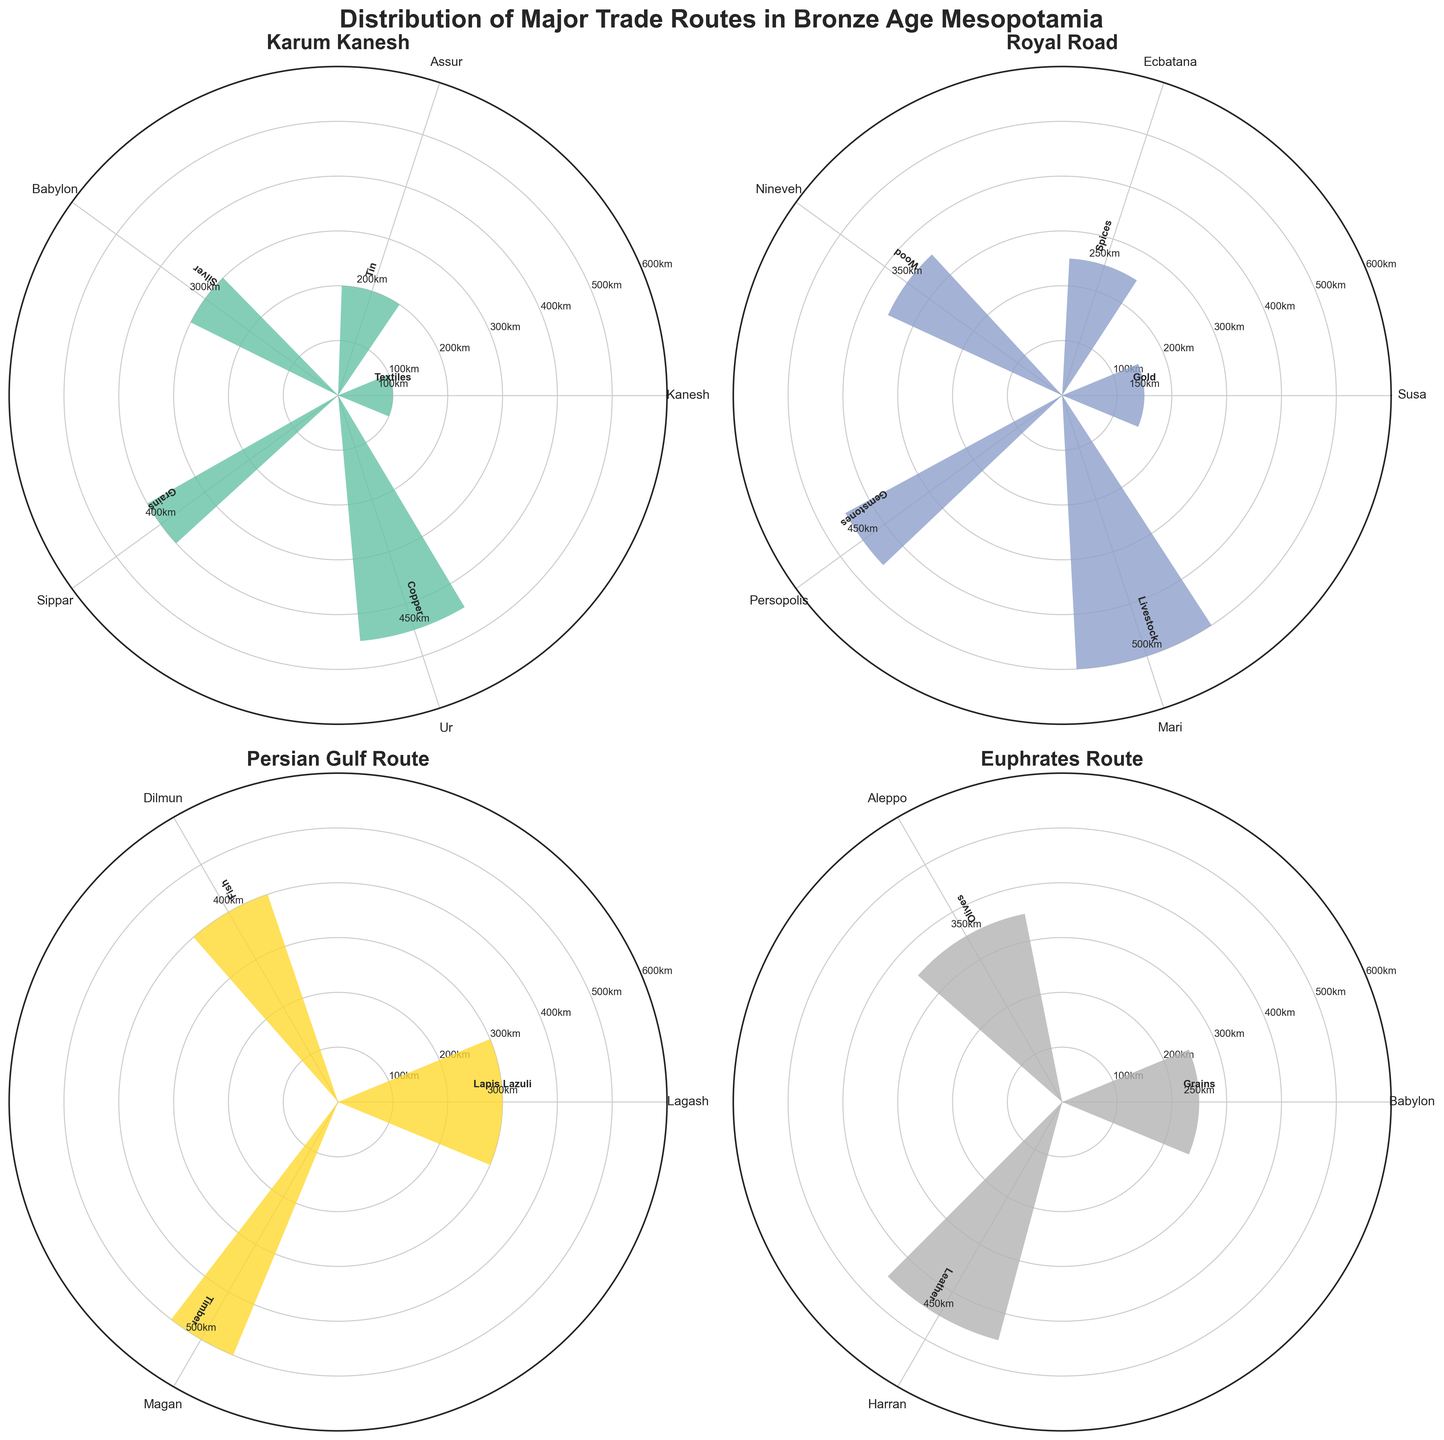What is the title of the figure? The title is displayed prominently at the top of the figure and reads 'Distribution of Major Trade Routes in Bronze Age Mesopotamia'
Answer: Distribution of Major Trade Routes in Bronze Age Mesopotamia Which trade route connects to the most trading centers? Each subplot represents a trade route, and counting the number of centers (bars) in each subplot shows that 'Karum Kanesh' and 'Royal Road' each have 5 centers, which is the most.
Answer: Karum Kanesh and Royal Road Which trading center on the Karum Kanesh route is the farthest distance from the starting point? On the subplot labeled 'Karum Kanesh', look for the longest bar which represents the farthest distance. 'Ur' has the longest bar.
Answer: Ur What kind of goods are traded most frequently on the Persian Gulf Route? On the subplot labeled 'Persian Gulf Route', count the frequency of each type of goods tagged near the bars. 'Lapis Lazuli' appears with the highest frequency of 6.
Answer: Lapis Lazuli Which two centers on the Royal Road have the same trading frequency? In the 'Royal Road' subplot, compare the width of the bars to find those of equal width. 'Ecbatana' and 'Mari' both have a frequency represented by a width of 4.
Answer: Ecbatana and Mari Which trade route has the shortest range of distances for its centers? By comparing the y-axis ranges of all subplots, 'Royal Road' ranges from 150 to 500, which covers 350 km, while other routes cover a wider range of distances.
Answer: Royal Road What is the combined frequency of goods traded to the cities of Kanesh and Assur on the Karum Kanesh route? In the 'Karum Kanesh' subplot, add the frequencies of 'Kanesh' (7) and 'Assur' (5): 7 + 5 = 12.
Answer: 12 On which route and to which center is livestock traded? From the labels near the bars, 'Royal Road' subplot includes 'Mari' trading 'Livestock'.
Answer: Royal Road to Mari Which trade route shows the trading of the most diverse kinds of goods? By counting the distinct types of goods across subplots, 'Karum Kanesh', 'Royal Road', and 'Euphrates Route' each trade five different kinds of goods, the maximum variety.
Answer: Karum Kanesh, Royal Road, and Euphrates Route What is the average distance for centers on the Euphrates Route? In the 'Euphrates Route' subplot, sum the distances (250 + 350 + 450 = 1050) and then divide by the number of centers (3): 1050 / 3 = 350.
Answer: 350 km 